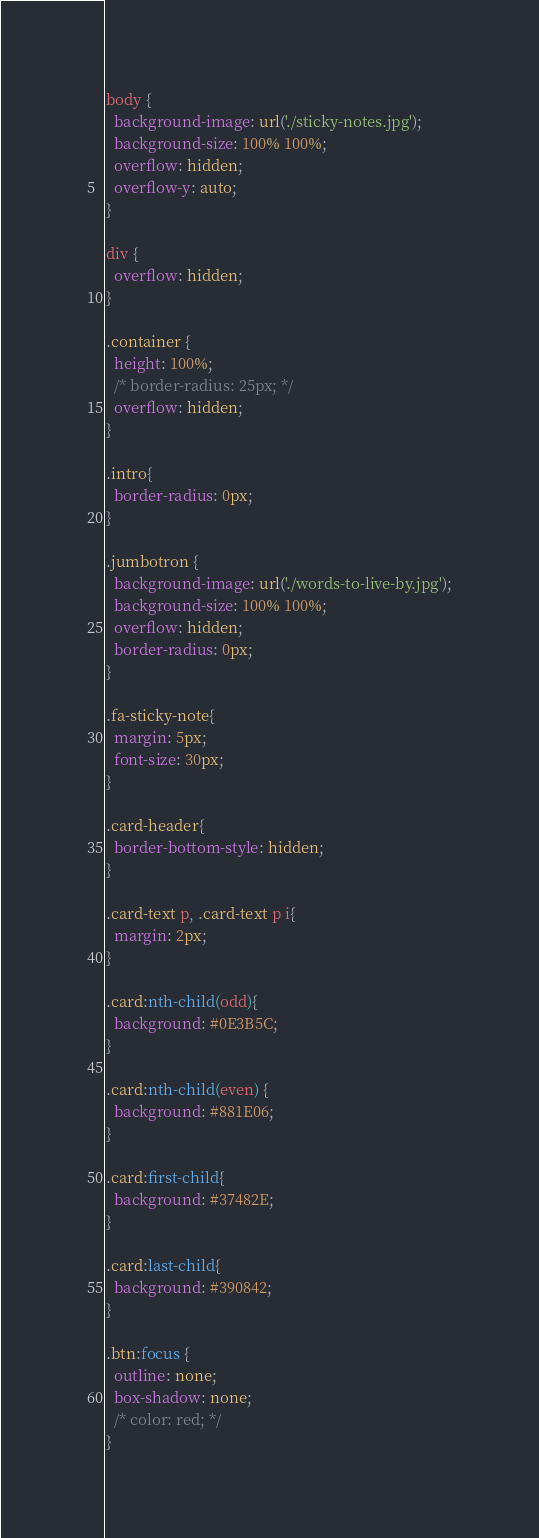<code> <loc_0><loc_0><loc_500><loc_500><_CSS_>body {
  background-image: url('./sticky-notes.jpg');
  background-size: 100% 100%;
  overflow: hidden;
  overflow-y: auto;
}

div {
  overflow: hidden;
}

.container {
  height: 100%;
  /* border-radius: 25px; */
  overflow: hidden;
}

.intro{
  border-radius: 0px;
}

.jumbotron {
  background-image: url('./words-to-live-by.jpg');
  background-size: 100% 100%;
  overflow: hidden;
  border-radius: 0px;
}

.fa-sticky-note{
  margin: 5px;
  font-size: 30px;
}

.card-header{
  border-bottom-style: hidden;
}

.card-text p, .card-text p i{
  margin: 2px;
}

.card:nth-child(odd){
  background: #0E3B5C;
}

.card:nth-child(even) {
  background: #881E06;
}

.card:first-child{
  background: #37482E;
}

.card:last-child{
  background: #390842;
}

.btn:focus {
  outline: none;
  box-shadow: none;
  /* color: red; */
}</code> 